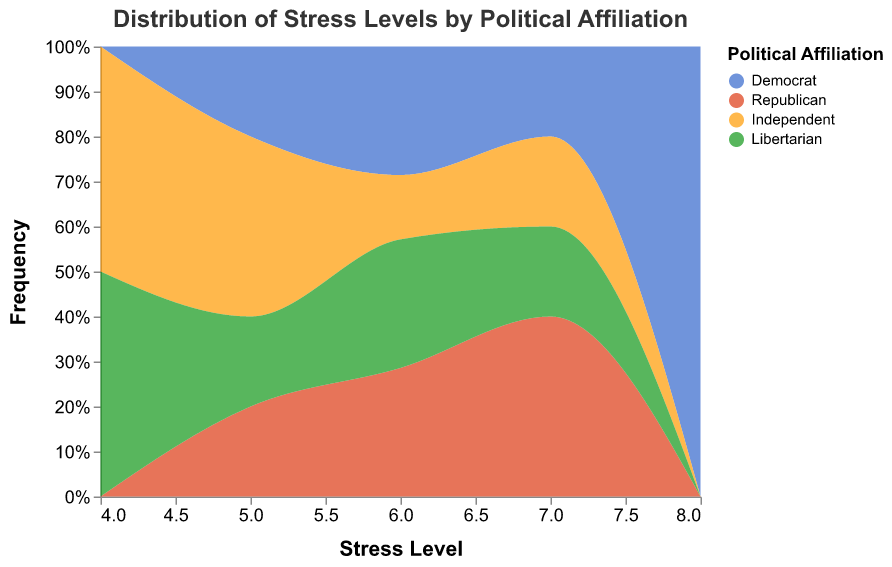What is the title of the plot? The title is usually one of the most noticeable elements at the top of the figure. This figure's title should summarize the visual content. The title given in the code is "Distribution of Stress Levels by Political Affiliation."
Answer: Distribution of Stress Levels by Political Affiliation Which political affiliation has the highest maximum stress level recorded? Looking at the plotting data for the figure, the maximum stress levels are indicated under "Stress_Level." The highest recorded levels appear to be '8' for Democrat as no other affiliation has a stress level of '8'.
Answer: Democrat What color represents Independent in this plot? The legend in the plot provides the color coding for each political affiliation. For Independent, according to the "color" definition, the range assigns "#ff9900" to Independent.
Answer: Orange Which stress level is most common for Republicans? By observing the frequency for each stress level, we see which stress level has the highest count for Republicans. From the dataset, stress levels of 6 and 7 are frequently recorded for Republicans.
Answer: 6 and 7 Which political affiliation has the most diverse (widest range) stress levels? To find the affiliation with the most diverse stress levels, we compare the range of stress levels for each. Democrats range from 5 to 8, Republicans range from 5 to 7, Independents from 4 to 7, and Libertarians from 4 to 7. Democrats have the widest range.
Answer: Democrat How do the stress levels of Libertarians compare to those of Independents? By comparing the frequency distributions for these two groups, we see the ranges and most common values. Both groups have a stress level range from 4 to 7, with similar frequencies at each level, indicating they have relatively similar distributions.
Answer: Similar What is the most common stress level in the entire dataset? By examining the x-axis and identifying where most areas (all colors combined) peak, we can determine the most frequent stress level across all affiliations. The highest combined peak appears around a stress level of 6.
Answer: 6 Compare the stress levels of Democrats and Republicans at level 6. Which group has more students at this level? By examining the height of the respective area segments at level 6 on the x-axis, we observe that the Republicans and Democrats have equivalent frequencies of students at a stress level of 6.
Answer: Equal How do the stress levels of Independent students vary compared to Democrat students? Comparing the distributions for these affiliations, Democrats have their stress levels spread from 5 to 8, whereas Independents range from 4 to 7. Independents show a lower variation toward the lower stress levels (4), while Democrats don't have any 4s but include an 8.
Answer: Different range 